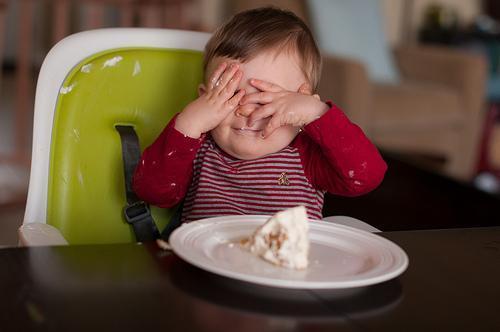How many chairs are there?
Give a very brief answer. 1. 